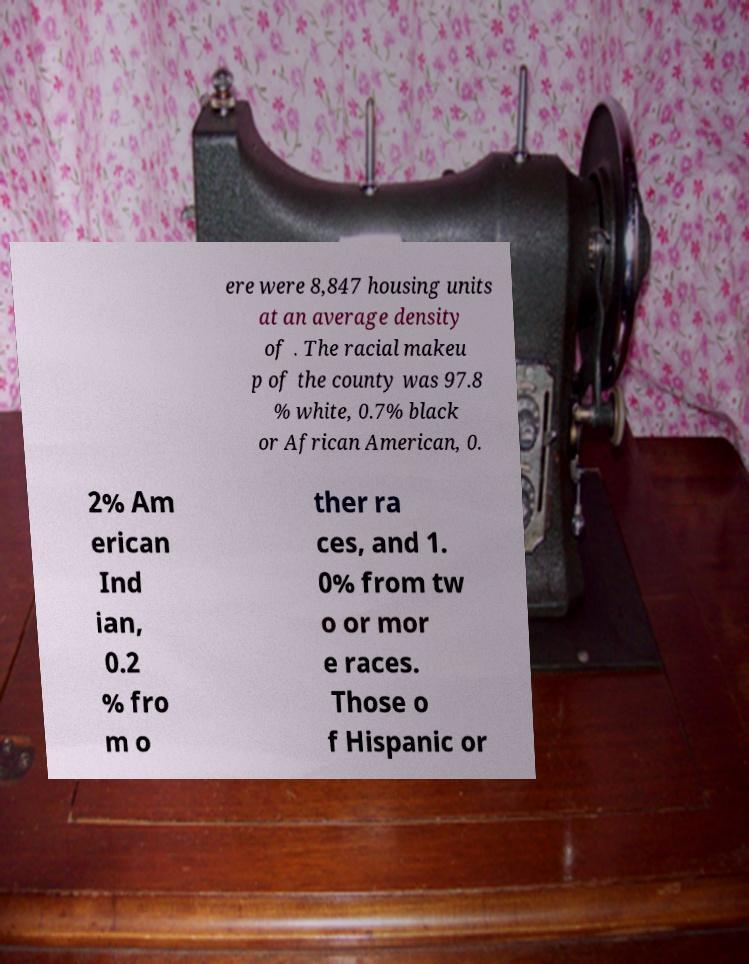Could you assist in decoding the text presented in this image and type it out clearly? ere were 8,847 housing units at an average density of . The racial makeu p of the county was 97.8 % white, 0.7% black or African American, 0. 2% Am erican Ind ian, 0.2 % fro m o ther ra ces, and 1. 0% from tw o or mor e races. Those o f Hispanic or 